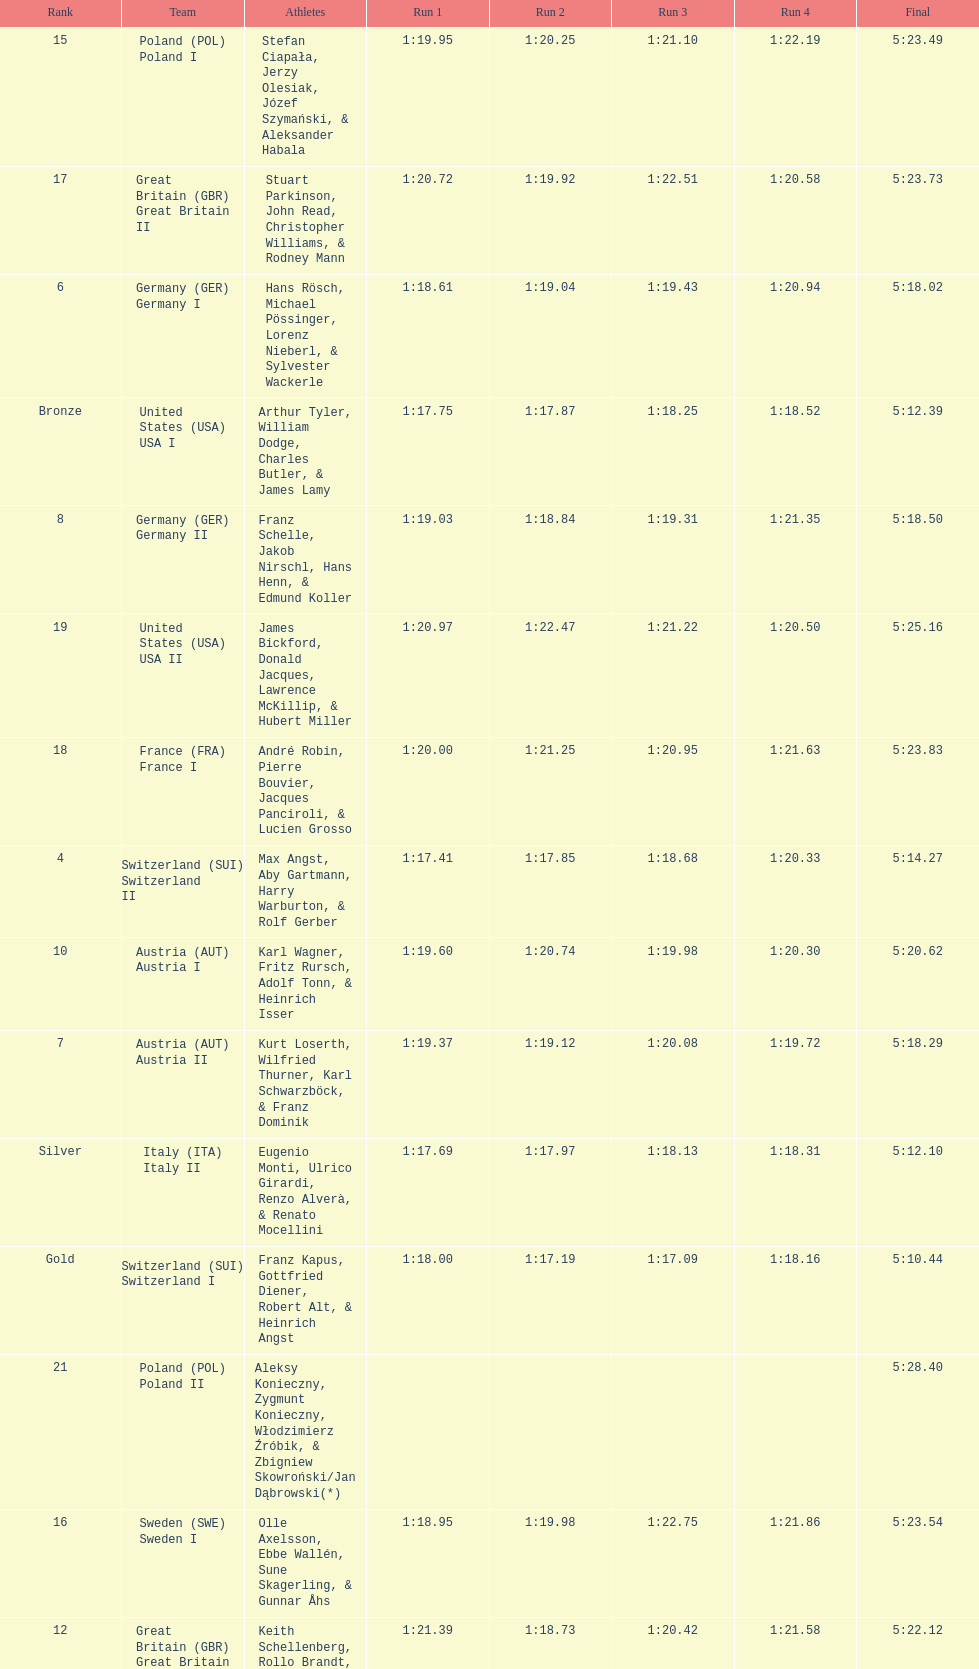How many teams did germany have? 2. 